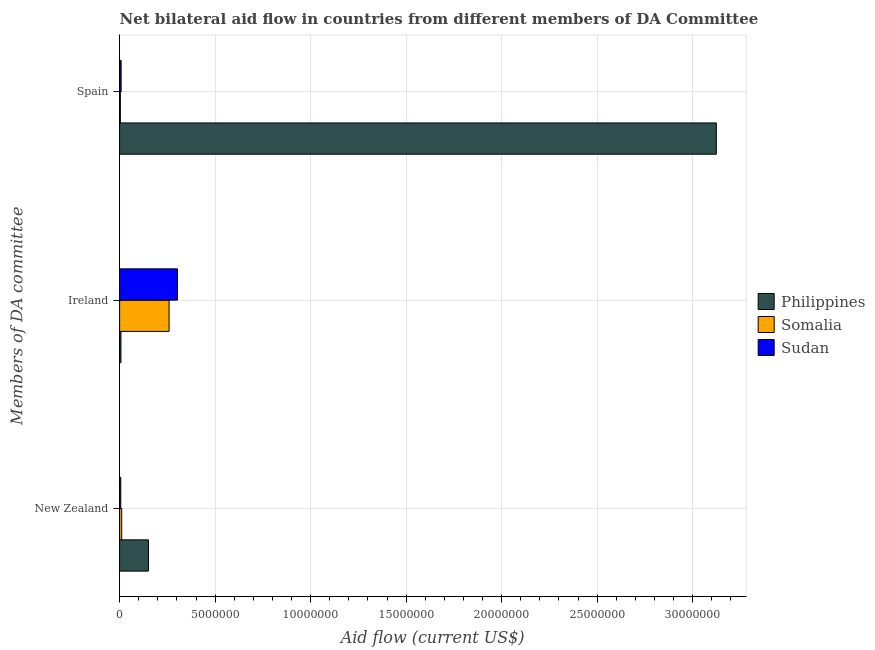How many different coloured bars are there?
Offer a terse response. 3. How many groups of bars are there?
Your response must be concise. 3. Are the number of bars on each tick of the Y-axis equal?
Offer a terse response. Yes. How many bars are there on the 2nd tick from the bottom?
Ensure brevity in your answer.  3. What is the amount of aid provided by ireland in Philippines?
Provide a succinct answer. 7.00e+04. Across all countries, what is the maximum amount of aid provided by new zealand?
Provide a short and direct response. 1.51e+06. Across all countries, what is the minimum amount of aid provided by ireland?
Keep it short and to the point. 7.00e+04. In which country was the amount of aid provided by new zealand maximum?
Keep it short and to the point. Philippines. What is the total amount of aid provided by new zealand in the graph?
Give a very brief answer. 1.68e+06. What is the difference between the amount of aid provided by spain in Philippines and that in Sudan?
Give a very brief answer. 3.12e+07. What is the difference between the amount of aid provided by ireland in Somalia and the amount of aid provided by new zealand in Philippines?
Provide a short and direct response. 1.08e+06. What is the average amount of aid provided by new zealand per country?
Provide a short and direct response. 5.60e+05. What is the difference between the amount of aid provided by ireland and amount of aid provided by new zealand in Somalia?
Offer a terse response. 2.48e+06. In how many countries, is the amount of aid provided by new zealand greater than 9000000 US$?
Offer a terse response. 0. What is the ratio of the amount of aid provided by ireland in Somalia to that in Sudan?
Offer a terse response. 0.85. Is the difference between the amount of aid provided by ireland in Sudan and Somalia greater than the difference between the amount of aid provided by new zealand in Sudan and Somalia?
Offer a terse response. Yes. What is the difference between the highest and the second highest amount of aid provided by ireland?
Your answer should be very brief. 4.40e+05. What is the difference between the highest and the lowest amount of aid provided by ireland?
Provide a short and direct response. 2.96e+06. What does the 2nd bar from the top in New Zealand represents?
Offer a very short reply. Somalia. What does the 3rd bar from the bottom in Ireland represents?
Offer a terse response. Sudan. How many countries are there in the graph?
Your answer should be compact. 3. What is the difference between two consecutive major ticks on the X-axis?
Provide a short and direct response. 5.00e+06. Does the graph contain grids?
Provide a succinct answer. Yes. How are the legend labels stacked?
Offer a terse response. Vertical. What is the title of the graph?
Provide a short and direct response. Net bilateral aid flow in countries from different members of DA Committee. Does "Togo" appear as one of the legend labels in the graph?
Make the answer very short. No. What is the label or title of the X-axis?
Provide a succinct answer. Aid flow (current US$). What is the label or title of the Y-axis?
Offer a terse response. Members of DA committee. What is the Aid flow (current US$) of Philippines in New Zealand?
Provide a short and direct response. 1.51e+06. What is the Aid flow (current US$) in Somalia in New Zealand?
Keep it short and to the point. 1.10e+05. What is the Aid flow (current US$) in Sudan in New Zealand?
Your response must be concise. 6.00e+04. What is the Aid flow (current US$) of Somalia in Ireland?
Make the answer very short. 2.59e+06. What is the Aid flow (current US$) of Sudan in Ireland?
Provide a succinct answer. 3.03e+06. What is the Aid flow (current US$) of Philippines in Spain?
Your response must be concise. 3.12e+07. What is the Aid flow (current US$) in Somalia in Spain?
Keep it short and to the point. 4.00e+04. What is the Aid flow (current US$) in Sudan in Spain?
Provide a short and direct response. 8.00e+04. Across all Members of DA committee, what is the maximum Aid flow (current US$) of Philippines?
Your response must be concise. 3.12e+07. Across all Members of DA committee, what is the maximum Aid flow (current US$) in Somalia?
Ensure brevity in your answer.  2.59e+06. Across all Members of DA committee, what is the maximum Aid flow (current US$) in Sudan?
Provide a short and direct response. 3.03e+06. Across all Members of DA committee, what is the minimum Aid flow (current US$) of Philippines?
Give a very brief answer. 7.00e+04. Across all Members of DA committee, what is the minimum Aid flow (current US$) of Somalia?
Your response must be concise. 4.00e+04. What is the total Aid flow (current US$) of Philippines in the graph?
Offer a very short reply. 3.28e+07. What is the total Aid flow (current US$) in Somalia in the graph?
Offer a terse response. 2.74e+06. What is the total Aid flow (current US$) of Sudan in the graph?
Ensure brevity in your answer.  3.17e+06. What is the difference between the Aid flow (current US$) in Philippines in New Zealand and that in Ireland?
Make the answer very short. 1.44e+06. What is the difference between the Aid flow (current US$) of Somalia in New Zealand and that in Ireland?
Ensure brevity in your answer.  -2.48e+06. What is the difference between the Aid flow (current US$) of Sudan in New Zealand and that in Ireland?
Your response must be concise. -2.97e+06. What is the difference between the Aid flow (current US$) of Philippines in New Zealand and that in Spain?
Ensure brevity in your answer.  -2.97e+07. What is the difference between the Aid flow (current US$) of Sudan in New Zealand and that in Spain?
Provide a short and direct response. -2.00e+04. What is the difference between the Aid flow (current US$) of Philippines in Ireland and that in Spain?
Offer a very short reply. -3.12e+07. What is the difference between the Aid flow (current US$) in Somalia in Ireland and that in Spain?
Keep it short and to the point. 2.55e+06. What is the difference between the Aid flow (current US$) in Sudan in Ireland and that in Spain?
Ensure brevity in your answer.  2.95e+06. What is the difference between the Aid flow (current US$) in Philippines in New Zealand and the Aid flow (current US$) in Somalia in Ireland?
Offer a terse response. -1.08e+06. What is the difference between the Aid flow (current US$) of Philippines in New Zealand and the Aid flow (current US$) of Sudan in Ireland?
Your response must be concise. -1.52e+06. What is the difference between the Aid flow (current US$) of Somalia in New Zealand and the Aid flow (current US$) of Sudan in Ireland?
Make the answer very short. -2.92e+06. What is the difference between the Aid flow (current US$) in Philippines in New Zealand and the Aid flow (current US$) in Somalia in Spain?
Keep it short and to the point. 1.47e+06. What is the difference between the Aid flow (current US$) of Philippines in New Zealand and the Aid flow (current US$) of Sudan in Spain?
Make the answer very short. 1.43e+06. What is the difference between the Aid flow (current US$) of Somalia in New Zealand and the Aid flow (current US$) of Sudan in Spain?
Your response must be concise. 3.00e+04. What is the difference between the Aid flow (current US$) in Philippines in Ireland and the Aid flow (current US$) in Sudan in Spain?
Make the answer very short. -10000. What is the difference between the Aid flow (current US$) in Somalia in Ireland and the Aid flow (current US$) in Sudan in Spain?
Keep it short and to the point. 2.51e+06. What is the average Aid flow (current US$) of Philippines per Members of DA committee?
Offer a very short reply. 1.09e+07. What is the average Aid flow (current US$) of Somalia per Members of DA committee?
Ensure brevity in your answer.  9.13e+05. What is the average Aid flow (current US$) in Sudan per Members of DA committee?
Offer a very short reply. 1.06e+06. What is the difference between the Aid flow (current US$) of Philippines and Aid flow (current US$) of Somalia in New Zealand?
Ensure brevity in your answer.  1.40e+06. What is the difference between the Aid flow (current US$) of Philippines and Aid flow (current US$) of Sudan in New Zealand?
Ensure brevity in your answer.  1.45e+06. What is the difference between the Aid flow (current US$) of Somalia and Aid flow (current US$) of Sudan in New Zealand?
Provide a succinct answer. 5.00e+04. What is the difference between the Aid flow (current US$) in Philippines and Aid flow (current US$) in Somalia in Ireland?
Ensure brevity in your answer.  -2.52e+06. What is the difference between the Aid flow (current US$) of Philippines and Aid flow (current US$) of Sudan in Ireland?
Provide a succinct answer. -2.96e+06. What is the difference between the Aid flow (current US$) of Somalia and Aid flow (current US$) of Sudan in Ireland?
Offer a terse response. -4.40e+05. What is the difference between the Aid flow (current US$) of Philippines and Aid flow (current US$) of Somalia in Spain?
Your answer should be very brief. 3.12e+07. What is the difference between the Aid flow (current US$) of Philippines and Aid flow (current US$) of Sudan in Spain?
Your answer should be very brief. 3.12e+07. What is the ratio of the Aid flow (current US$) of Philippines in New Zealand to that in Ireland?
Your response must be concise. 21.57. What is the ratio of the Aid flow (current US$) of Somalia in New Zealand to that in Ireland?
Give a very brief answer. 0.04. What is the ratio of the Aid flow (current US$) in Sudan in New Zealand to that in Ireland?
Your response must be concise. 0.02. What is the ratio of the Aid flow (current US$) of Philippines in New Zealand to that in Spain?
Provide a succinct answer. 0.05. What is the ratio of the Aid flow (current US$) of Somalia in New Zealand to that in Spain?
Provide a succinct answer. 2.75. What is the ratio of the Aid flow (current US$) of Sudan in New Zealand to that in Spain?
Your answer should be compact. 0.75. What is the ratio of the Aid flow (current US$) in Philippines in Ireland to that in Spain?
Offer a very short reply. 0. What is the ratio of the Aid flow (current US$) in Somalia in Ireland to that in Spain?
Provide a succinct answer. 64.75. What is the ratio of the Aid flow (current US$) in Sudan in Ireland to that in Spain?
Provide a succinct answer. 37.88. What is the difference between the highest and the second highest Aid flow (current US$) of Philippines?
Make the answer very short. 2.97e+07. What is the difference between the highest and the second highest Aid flow (current US$) in Somalia?
Provide a succinct answer. 2.48e+06. What is the difference between the highest and the second highest Aid flow (current US$) in Sudan?
Ensure brevity in your answer.  2.95e+06. What is the difference between the highest and the lowest Aid flow (current US$) in Philippines?
Provide a short and direct response. 3.12e+07. What is the difference between the highest and the lowest Aid flow (current US$) of Somalia?
Offer a terse response. 2.55e+06. What is the difference between the highest and the lowest Aid flow (current US$) in Sudan?
Keep it short and to the point. 2.97e+06. 